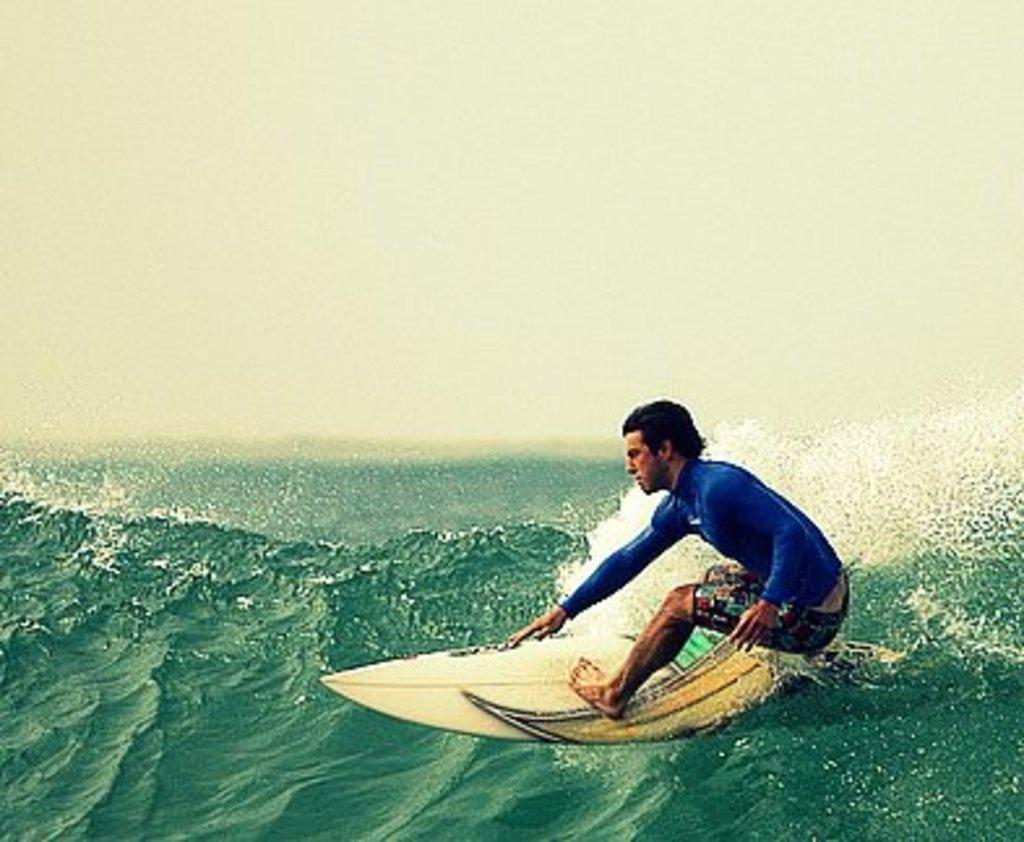Who is the person in the image? There is a man in the image. What is the man doing in the image? The man is surfing. What tool is the man using to surf? The man is using a surfboard. Where is the surfboard located in the image? The surfboard is on the water. What natural elements can be seen in the image? Water and sky are visible in the image. What feature of the water can be observed in the image? There appears to be a wave in the water. Can you see any caves in the image? There are no caves visible in the image. Are there any giants surfing alongside the man in the image? There are no giants present in the image; only the man is surfing. 